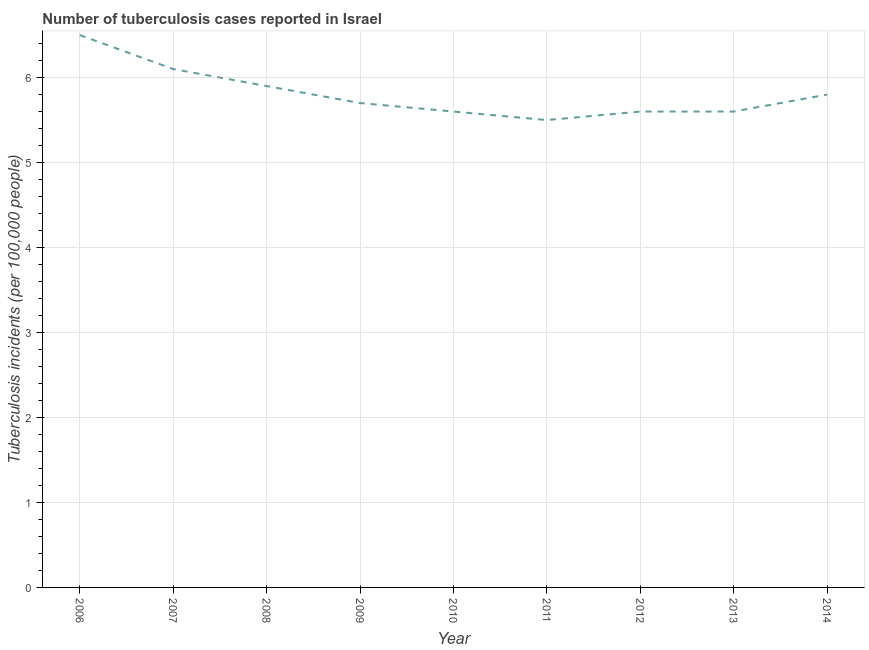What is the number of tuberculosis incidents in 2013?
Your answer should be compact. 5.6. Across all years, what is the maximum number of tuberculosis incidents?
Provide a succinct answer. 6.5. In which year was the number of tuberculosis incidents maximum?
Provide a short and direct response. 2006. What is the sum of the number of tuberculosis incidents?
Ensure brevity in your answer.  52.3. What is the difference between the number of tuberculosis incidents in 2010 and 2011?
Keep it short and to the point. 0.1. What is the average number of tuberculosis incidents per year?
Make the answer very short. 5.81. What is the median number of tuberculosis incidents?
Provide a short and direct response. 5.7. In how many years, is the number of tuberculosis incidents greater than 1.8 ?
Provide a short and direct response. 9. What is the ratio of the number of tuberculosis incidents in 2010 to that in 2012?
Offer a very short reply. 1. What is the difference between the highest and the second highest number of tuberculosis incidents?
Offer a very short reply. 0.4. In how many years, is the number of tuberculosis incidents greater than the average number of tuberculosis incidents taken over all years?
Your answer should be compact. 3. What is the difference between two consecutive major ticks on the Y-axis?
Provide a short and direct response. 1. Are the values on the major ticks of Y-axis written in scientific E-notation?
Ensure brevity in your answer.  No. Does the graph contain any zero values?
Keep it short and to the point. No. What is the title of the graph?
Offer a very short reply. Number of tuberculosis cases reported in Israel. What is the label or title of the Y-axis?
Make the answer very short. Tuberculosis incidents (per 100,0 people). What is the Tuberculosis incidents (per 100,000 people) in 2006?
Offer a terse response. 6.5. What is the Tuberculosis incidents (per 100,000 people) in 2007?
Offer a terse response. 6.1. What is the Tuberculosis incidents (per 100,000 people) in 2011?
Give a very brief answer. 5.5. What is the Tuberculosis incidents (per 100,000 people) of 2014?
Offer a very short reply. 5.8. What is the difference between the Tuberculosis incidents (per 100,000 people) in 2006 and 2007?
Offer a terse response. 0.4. What is the difference between the Tuberculosis incidents (per 100,000 people) in 2007 and 2009?
Ensure brevity in your answer.  0.4. What is the difference between the Tuberculosis incidents (per 100,000 people) in 2007 and 2010?
Your response must be concise. 0.5. What is the difference between the Tuberculosis incidents (per 100,000 people) in 2007 and 2012?
Your answer should be very brief. 0.5. What is the difference between the Tuberculosis incidents (per 100,000 people) in 2008 and 2009?
Offer a very short reply. 0.2. What is the difference between the Tuberculosis incidents (per 100,000 people) in 2008 and 2011?
Offer a terse response. 0.4. What is the difference between the Tuberculosis incidents (per 100,000 people) in 2009 and 2011?
Offer a very short reply. 0.2. What is the difference between the Tuberculosis incidents (per 100,000 people) in 2009 and 2012?
Offer a very short reply. 0.1. What is the difference between the Tuberculosis incidents (per 100,000 people) in 2010 and 2011?
Give a very brief answer. 0.1. What is the difference between the Tuberculosis incidents (per 100,000 people) in 2010 and 2012?
Your response must be concise. 0. What is the difference between the Tuberculosis incidents (per 100,000 people) in 2010 and 2013?
Keep it short and to the point. 0. What is the difference between the Tuberculosis incidents (per 100,000 people) in 2011 and 2014?
Provide a short and direct response. -0.3. What is the difference between the Tuberculosis incidents (per 100,000 people) in 2012 and 2013?
Keep it short and to the point. 0. What is the ratio of the Tuberculosis incidents (per 100,000 people) in 2006 to that in 2007?
Keep it short and to the point. 1.07. What is the ratio of the Tuberculosis incidents (per 100,000 people) in 2006 to that in 2008?
Give a very brief answer. 1.1. What is the ratio of the Tuberculosis incidents (per 100,000 people) in 2006 to that in 2009?
Make the answer very short. 1.14. What is the ratio of the Tuberculosis incidents (per 100,000 people) in 2006 to that in 2010?
Your response must be concise. 1.16. What is the ratio of the Tuberculosis incidents (per 100,000 people) in 2006 to that in 2011?
Your response must be concise. 1.18. What is the ratio of the Tuberculosis incidents (per 100,000 people) in 2006 to that in 2012?
Make the answer very short. 1.16. What is the ratio of the Tuberculosis incidents (per 100,000 people) in 2006 to that in 2013?
Provide a short and direct response. 1.16. What is the ratio of the Tuberculosis incidents (per 100,000 people) in 2006 to that in 2014?
Ensure brevity in your answer.  1.12. What is the ratio of the Tuberculosis incidents (per 100,000 people) in 2007 to that in 2008?
Provide a succinct answer. 1.03. What is the ratio of the Tuberculosis incidents (per 100,000 people) in 2007 to that in 2009?
Your response must be concise. 1.07. What is the ratio of the Tuberculosis incidents (per 100,000 people) in 2007 to that in 2010?
Ensure brevity in your answer.  1.09. What is the ratio of the Tuberculosis incidents (per 100,000 people) in 2007 to that in 2011?
Provide a short and direct response. 1.11. What is the ratio of the Tuberculosis incidents (per 100,000 people) in 2007 to that in 2012?
Keep it short and to the point. 1.09. What is the ratio of the Tuberculosis incidents (per 100,000 people) in 2007 to that in 2013?
Keep it short and to the point. 1.09. What is the ratio of the Tuberculosis incidents (per 100,000 people) in 2007 to that in 2014?
Offer a very short reply. 1.05. What is the ratio of the Tuberculosis incidents (per 100,000 people) in 2008 to that in 2009?
Offer a terse response. 1.03. What is the ratio of the Tuberculosis incidents (per 100,000 people) in 2008 to that in 2010?
Your answer should be compact. 1.05. What is the ratio of the Tuberculosis incidents (per 100,000 people) in 2008 to that in 2011?
Provide a succinct answer. 1.07. What is the ratio of the Tuberculosis incidents (per 100,000 people) in 2008 to that in 2012?
Give a very brief answer. 1.05. What is the ratio of the Tuberculosis incidents (per 100,000 people) in 2008 to that in 2013?
Provide a short and direct response. 1.05. What is the ratio of the Tuberculosis incidents (per 100,000 people) in 2009 to that in 2010?
Make the answer very short. 1.02. What is the ratio of the Tuberculosis incidents (per 100,000 people) in 2009 to that in 2011?
Make the answer very short. 1.04. What is the ratio of the Tuberculosis incidents (per 100,000 people) in 2009 to that in 2012?
Give a very brief answer. 1.02. What is the ratio of the Tuberculosis incidents (per 100,000 people) in 2009 to that in 2013?
Make the answer very short. 1.02. What is the ratio of the Tuberculosis incidents (per 100,000 people) in 2009 to that in 2014?
Make the answer very short. 0.98. What is the ratio of the Tuberculosis incidents (per 100,000 people) in 2010 to that in 2011?
Make the answer very short. 1.02. What is the ratio of the Tuberculosis incidents (per 100,000 people) in 2010 to that in 2013?
Keep it short and to the point. 1. What is the ratio of the Tuberculosis incidents (per 100,000 people) in 2010 to that in 2014?
Provide a short and direct response. 0.97. What is the ratio of the Tuberculosis incidents (per 100,000 people) in 2011 to that in 2013?
Your answer should be very brief. 0.98. What is the ratio of the Tuberculosis incidents (per 100,000 people) in 2011 to that in 2014?
Ensure brevity in your answer.  0.95. What is the ratio of the Tuberculosis incidents (per 100,000 people) in 2012 to that in 2013?
Ensure brevity in your answer.  1. What is the ratio of the Tuberculosis incidents (per 100,000 people) in 2012 to that in 2014?
Provide a succinct answer. 0.97. What is the ratio of the Tuberculosis incidents (per 100,000 people) in 2013 to that in 2014?
Offer a terse response. 0.97. 